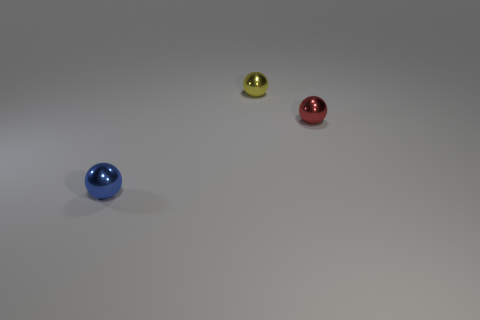Is the tiny yellow object the same shape as the small red metallic object?
Offer a terse response. Yes. What number of small things are red shiny things or green metal cylinders?
Provide a short and direct response. 1. Is the number of blue metallic things greater than the number of purple rubber balls?
Your response must be concise. Yes. There is a blue sphere that is made of the same material as the yellow ball; what is its size?
Offer a terse response. Small. Is the size of the sphere that is right of the small yellow metallic object the same as the ball that is in front of the red shiny ball?
Make the answer very short. Yes. How many objects are small metallic balls behind the tiny red sphere or small blue things?
Provide a short and direct response. 2. Is the number of blue metallic spheres less than the number of shiny balls?
Your answer should be compact. Yes. What shape is the metallic thing behind the tiny metal ball right of the metallic ball behind the tiny red thing?
Keep it short and to the point. Sphere. Is there a small yellow thing?
Offer a very short reply. Yes. Do the red shiny object and the shiny object that is behind the red ball have the same size?
Give a very brief answer. Yes. 